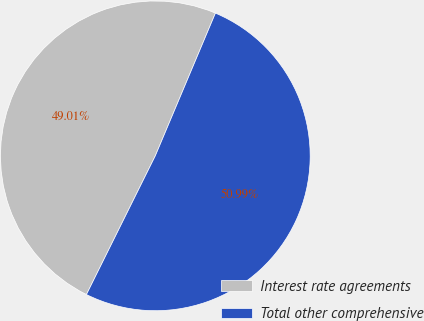Convert chart. <chart><loc_0><loc_0><loc_500><loc_500><pie_chart><fcel>Interest rate agreements<fcel>Total other comprehensive<nl><fcel>49.01%<fcel>50.99%<nl></chart> 